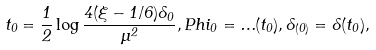<formula> <loc_0><loc_0><loc_500><loc_500>t _ { 0 } = \frac { 1 } { 2 } \log \frac { 4 ( \xi - 1 / 6 ) \Lambda _ { 0 } } { \mu ^ { 2 } } , P h i _ { 0 } = \Phi ( t _ { 0 } ) , \Lambda _ { ( 0 ) } = \Lambda ( t _ { 0 } ) ,</formula> 